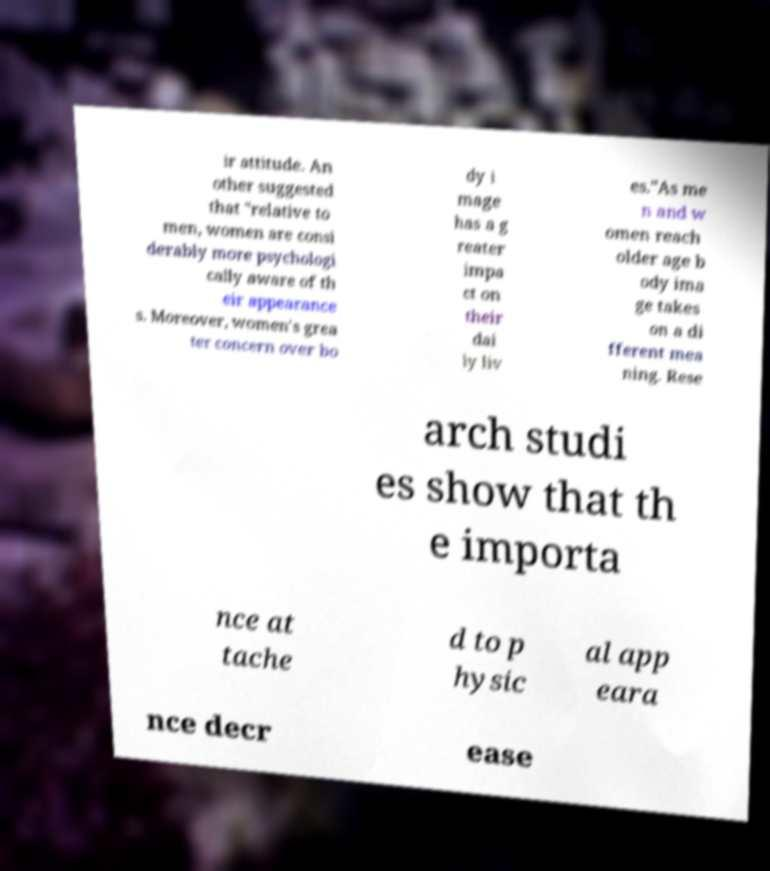There's text embedded in this image that I need extracted. Can you transcribe it verbatim? ir attitude. An other suggested that "relative to men, women are consi derably more psychologi cally aware of th eir appearance s. Moreover, women's grea ter concern over bo dy i mage has a g reater impa ct on their dai ly liv es."As me n and w omen reach older age b ody ima ge takes on a di fferent mea ning. Rese arch studi es show that th e importa nce at tache d to p hysic al app eara nce decr ease 